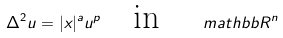Convert formula to latex. <formula><loc_0><loc_0><loc_500><loc_500>\Delta ^ { 2 } u = | x | ^ { a } u ^ { p } \quad \text {in } \quad m a t h b b { R } ^ { n }</formula> 